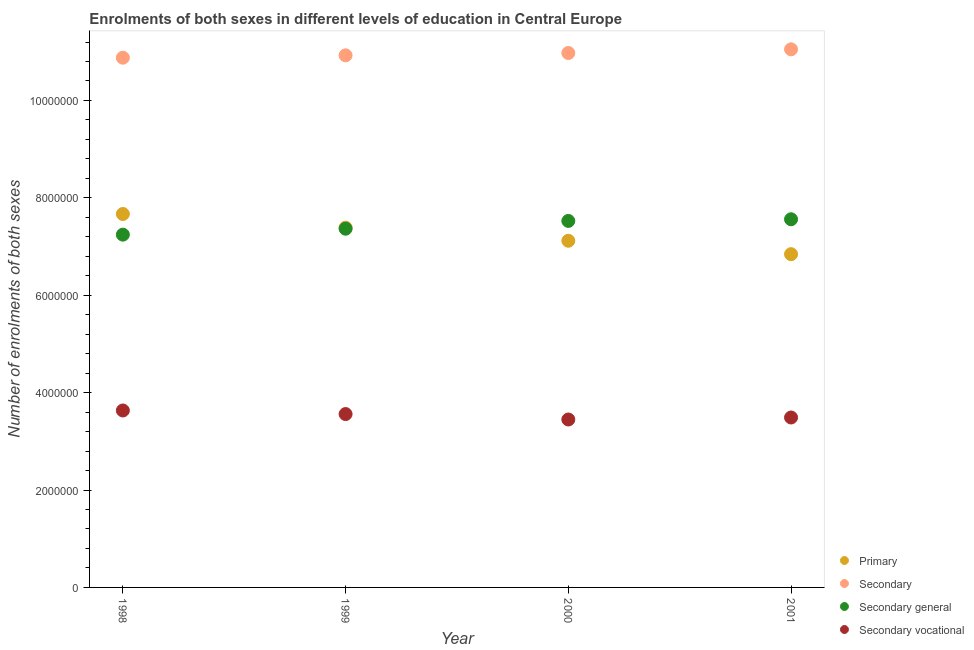How many different coloured dotlines are there?
Make the answer very short. 4. What is the number of enrolments in secondary education in 2000?
Provide a succinct answer. 1.10e+07. Across all years, what is the maximum number of enrolments in secondary general education?
Provide a succinct answer. 7.56e+06. Across all years, what is the minimum number of enrolments in primary education?
Provide a succinct answer. 6.84e+06. In which year was the number of enrolments in secondary education maximum?
Provide a succinct answer. 2001. In which year was the number of enrolments in secondary education minimum?
Give a very brief answer. 1998. What is the total number of enrolments in primary education in the graph?
Ensure brevity in your answer.  2.90e+07. What is the difference between the number of enrolments in secondary education in 1999 and that in 2000?
Your answer should be compact. -4.81e+04. What is the difference between the number of enrolments in primary education in 1999 and the number of enrolments in secondary education in 1998?
Offer a very short reply. -3.49e+06. What is the average number of enrolments in secondary education per year?
Your response must be concise. 1.10e+07. In the year 1999, what is the difference between the number of enrolments in secondary education and number of enrolments in secondary vocational education?
Provide a short and direct response. 7.37e+06. In how many years, is the number of enrolments in secondary vocational education greater than 10400000?
Provide a succinct answer. 0. What is the ratio of the number of enrolments in secondary vocational education in 1999 to that in 2000?
Provide a succinct answer. 1.03. What is the difference between the highest and the second highest number of enrolments in secondary vocational education?
Your answer should be very brief. 7.35e+04. What is the difference between the highest and the lowest number of enrolments in primary education?
Give a very brief answer. 8.25e+05. Is the sum of the number of enrolments in primary education in 2000 and 2001 greater than the maximum number of enrolments in secondary vocational education across all years?
Offer a terse response. Yes. Is it the case that in every year, the sum of the number of enrolments in primary education and number of enrolments in secondary education is greater than the number of enrolments in secondary general education?
Ensure brevity in your answer.  Yes. Is the number of enrolments in secondary vocational education strictly greater than the number of enrolments in secondary education over the years?
Provide a succinct answer. No. How many dotlines are there?
Offer a terse response. 4. Are the values on the major ticks of Y-axis written in scientific E-notation?
Give a very brief answer. No. Does the graph contain any zero values?
Ensure brevity in your answer.  No. Does the graph contain grids?
Ensure brevity in your answer.  No. How many legend labels are there?
Provide a short and direct response. 4. What is the title of the graph?
Keep it short and to the point. Enrolments of both sexes in different levels of education in Central Europe. What is the label or title of the X-axis?
Your answer should be compact. Year. What is the label or title of the Y-axis?
Your answer should be very brief. Number of enrolments of both sexes. What is the Number of enrolments of both sexes in Primary in 1998?
Your answer should be very brief. 7.67e+06. What is the Number of enrolments of both sexes in Secondary in 1998?
Keep it short and to the point. 1.09e+07. What is the Number of enrolments of both sexes in Secondary general in 1998?
Your answer should be compact. 7.24e+06. What is the Number of enrolments of both sexes of Secondary vocational in 1998?
Ensure brevity in your answer.  3.63e+06. What is the Number of enrolments of both sexes of Primary in 1999?
Your answer should be very brief. 7.39e+06. What is the Number of enrolments of both sexes of Secondary in 1999?
Ensure brevity in your answer.  1.09e+07. What is the Number of enrolments of both sexes in Secondary general in 1999?
Ensure brevity in your answer.  7.37e+06. What is the Number of enrolments of both sexes in Secondary vocational in 1999?
Provide a succinct answer. 3.56e+06. What is the Number of enrolments of both sexes in Primary in 2000?
Provide a short and direct response. 7.12e+06. What is the Number of enrolments of both sexes of Secondary in 2000?
Make the answer very short. 1.10e+07. What is the Number of enrolments of both sexes of Secondary general in 2000?
Your response must be concise. 7.53e+06. What is the Number of enrolments of both sexes of Secondary vocational in 2000?
Your answer should be compact. 3.45e+06. What is the Number of enrolments of both sexes in Primary in 2001?
Your answer should be compact. 6.84e+06. What is the Number of enrolments of both sexes in Secondary in 2001?
Give a very brief answer. 1.10e+07. What is the Number of enrolments of both sexes of Secondary general in 2001?
Provide a succinct answer. 7.56e+06. What is the Number of enrolments of both sexes in Secondary vocational in 2001?
Keep it short and to the point. 3.49e+06. Across all years, what is the maximum Number of enrolments of both sexes of Primary?
Your answer should be compact. 7.67e+06. Across all years, what is the maximum Number of enrolments of both sexes of Secondary?
Offer a terse response. 1.10e+07. Across all years, what is the maximum Number of enrolments of both sexes in Secondary general?
Provide a succinct answer. 7.56e+06. Across all years, what is the maximum Number of enrolments of both sexes of Secondary vocational?
Your answer should be compact. 3.63e+06. Across all years, what is the minimum Number of enrolments of both sexes in Primary?
Offer a very short reply. 6.84e+06. Across all years, what is the minimum Number of enrolments of both sexes in Secondary?
Offer a terse response. 1.09e+07. Across all years, what is the minimum Number of enrolments of both sexes in Secondary general?
Your answer should be very brief. 7.24e+06. Across all years, what is the minimum Number of enrolments of both sexes of Secondary vocational?
Give a very brief answer. 3.45e+06. What is the total Number of enrolments of both sexes in Primary in the graph?
Offer a very short reply. 2.90e+07. What is the total Number of enrolments of both sexes of Secondary in the graph?
Your answer should be very brief. 4.38e+07. What is the total Number of enrolments of both sexes in Secondary general in the graph?
Provide a succinct answer. 2.97e+07. What is the total Number of enrolments of both sexes in Secondary vocational in the graph?
Ensure brevity in your answer.  1.41e+07. What is the difference between the Number of enrolments of both sexes in Primary in 1998 and that in 1999?
Your answer should be compact. 2.81e+05. What is the difference between the Number of enrolments of both sexes in Secondary in 1998 and that in 1999?
Keep it short and to the point. -4.83e+04. What is the difference between the Number of enrolments of both sexes in Secondary general in 1998 and that in 1999?
Your answer should be very brief. -1.22e+05. What is the difference between the Number of enrolments of both sexes in Secondary vocational in 1998 and that in 1999?
Provide a succinct answer. 7.35e+04. What is the difference between the Number of enrolments of both sexes in Primary in 1998 and that in 2000?
Keep it short and to the point. 5.50e+05. What is the difference between the Number of enrolments of both sexes in Secondary in 1998 and that in 2000?
Your answer should be compact. -9.64e+04. What is the difference between the Number of enrolments of both sexes of Secondary general in 1998 and that in 2000?
Keep it short and to the point. -2.82e+05. What is the difference between the Number of enrolments of both sexes of Secondary vocational in 1998 and that in 2000?
Offer a terse response. 1.85e+05. What is the difference between the Number of enrolments of both sexes in Primary in 1998 and that in 2001?
Offer a very short reply. 8.25e+05. What is the difference between the Number of enrolments of both sexes of Secondary in 1998 and that in 2001?
Keep it short and to the point. -1.72e+05. What is the difference between the Number of enrolments of both sexes of Secondary general in 1998 and that in 2001?
Your answer should be compact. -3.16e+05. What is the difference between the Number of enrolments of both sexes of Secondary vocational in 1998 and that in 2001?
Ensure brevity in your answer.  1.44e+05. What is the difference between the Number of enrolments of both sexes of Primary in 1999 and that in 2000?
Keep it short and to the point. 2.68e+05. What is the difference between the Number of enrolments of both sexes in Secondary in 1999 and that in 2000?
Ensure brevity in your answer.  -4.81e+04. What is the difference between the Number of enrolments of both sexes in Secondary general in 1999 and that in 2000?
Your answer should be compact. -1.60e+05. What is the difference between the Number of enrolments of both sexes in Secondary vocational in 1999 and that in 2000?
Ensure brevity in your answer.  1.12e+05. What is the difference between the Number of enrolments of both sexes of Primary in 1999 and that in 2001?
Provide a short and direct response. 5.44e+05. What is the difference between the Number of enrolments of both sexes of Secondary in 1999 and that in 2001?
Offer a very short reply. -1.23e+05. What is the difference between the Number of enrolments of both sexes in Secondary general in 1999 and that in 2001?
Make the answer very short. -1.94e+05. What is the difference between the Number of enrolments of both sexes of Secondary vocational in 1999 and that in 2001?
Provide a short and direct response. 7.03e+04. What is the difference between the Number of enrolments of both sexes of Primary in 2000 and that in 2001?
Keep it short and to the point. 2.75e+05. What is the difference between the Number of enrolments of both sexes in Secondary in 2000 and that in 2001?
Give a very brief answer. -7.53e+04. What is the difference between the Number of enrolments of both sexes of Secondary general in 2000 and that in 2001?
Keep it short and to the point. -3.40e+04. What is the difference between the Number of enrolments of both sexes in Secondary vocational in 2000 and that in 2001?
Make the answer very short. -4.13e+04. What is the difference between the Number of enrolments of both sexes in Primary in 1998 and the Number of enrolments of both sexes in Secondary in 1999?
Give a very brief answer. -3.26e+06. What is the difference between the Number of enrolments of both sexes in Primary in 1998 and the Number of enrolments of both sexes in Secondary general in 1999?
Offer a very short reply. 3.02e+05. What is the difference between the Number of enrolments of both sexes of Primary in 1998 and the Number of enrolments of both sexes of Secondary vocational in 1999?
Make the answer very short. 4.11e+06. What is the difference between the Number of enrolments of both sexes in Secondary in 1998 and the Number of enrolments of both sexes in Secondary general in 1999?
Give a very brief answer. 3.51e+06. What is the difference between the Number of enrolments of both sexes in Secondary in 1998 and the Number of enrolments of both sexes in Secondary vocational in 1999?
Your answer should be compact. 7.32e+06. What is the difference between the Number of enrolments of both sexes of Secondary general in 1998 and the Number of enrolments of both sexes of Secondary vocational in 1999?
Your answer should be very brief. 3.68e+06. What is the difference between the Number of enrolments of both sexes of Primary in 1998 and the Number of enrolments of both sexes of Secondary in 2000?
Offer a terse response. -3.31e+06. What is the difference between the Number of enrolments of both sexes in Primary in 1998 and the Number of enrolments of both sexes in Secondary general in 2000?
Provide a succinct answer. 1.42e+05. What is the difference between the Number of enrolments of both sexes in Primary in 1998 and the Number of enrolments of both sexes in Secondary vocational in 2000?
Give a very brief answer. 4.22e+06. What is the difference between the Number of enrolments of both sexes of Secondary in 1998 and the Number of enrolments of both sexes of Secondary general in 2000?
Make the answer very short. 3.35e+06. What is the difference between the Number of enrolments of both sexes in Secondary in 1998 and the Number of enrolments of both sexes in Secondary vocational in 2000?
Offer a terse response. 7.43e+06. What is the difference between the Number of enrolments of both sexes in Secondary general in 1998 and the Number of enrolments of both sexes in Secondary vocational in 2000?
Make the answer very short. 3.80e+06. What is the difference between the Number of enrolments of both sexes in Primary in 1998 and the Number of enrolments of both sexes in Secondary in 2001?
Offer a very short reply. -3.38e+06. What is the difference between the Number of enrolments of both sexes of Primary in 1998 and the Number of enrolments of both sexes of Secondary general in 2001?
Provide a short and direct response. 1.08e+05. What is the difference between the Number of enrolments of both sexes in Primary in 1998 and the Number of enrolments of both sexes in Secondary vocational in 2001?
Offer a very short reply. 4.18e+06. What is the difference between the Number of enrolments of both sexes in Secondary in 1998 and the Number of enrolments of both sexes in Secondary general in 2001?
Your answer should be very brief. 3.32e+06. What is the difference between the Number of enrolments of both sexes in Secondary in 1998 and the Number of enrolments of both sexes in Secondary vocational in 2001?
Your response must be concise. 7.39e+06. What is the difference between the Number of enrolments of both sexes in Secondary general in 1998 and the Number of enrolments of both sexes in Secondary vocational in 2001?
Keep it short and to the point. 3.75e+06. What is the difference between the Number of enrolments of both sexes in Primary in 1999 and the Number of enrolments of both sexes in Secondary in 2000?
Provide a succinct answer. -3.59e+06. What is the difference between the Number of enrolments of both sexes of Primary in 1999 and the Number of enrolments of both sexes of Secondary general in 2000?
Make the answer very short. -1.39e+05. What is the difference between the Number of enrolments of both sexes of Primary in 1999 and the Number of enrolments of both sexes of Secondary vocational in 2000?
Make the answer very short. 3.94e+06. What is the difference between the Number of enrolments of both sexes in Secondary in 1999 and the Number of enrolments of both sexes in Secondary general in 2000?
Offer a terse response. 3.40e+06. What is the difference between the Number of enrolments of both sexes of Secondary in 1999 and the Number of enrolments of both sexes of Secondary vocational in 2000?
Your answer should be compact. 7.48e+06. What is the difference between the Number of enrolments of both sexes in Secondary general in 1999 and the Number of enrolments of both sexes in Secondary vocational in 2000?
Your answer should be very brief. 3.92e+06. What is the difference between the Number of enrolments of both sexes of Primary in 1999 and the Number of enrolments of both sexes of Secondary in 2001?
Offer a very short reply. -3.66e+06. What is the difference between the Number of enrolments of both sexes in Primary in 1999 and the Number of enrolments of both sexes in Secondary general in 2001?
Keep it short and to the point. -1.73e+05. What is the difference between the Number of enrolments of both sexes in Primary in 1999 and the Number of enrolments of both sexes in Secondary vocational in 2001?
Provide a succinct answer. 3.90e+06. What is the difference between the Number of enrolments of both sexes in Secondary in 1999 and the Number of enrolments of both sexes in Secondary general in 2001?
Make the answer very short. 3.37e+06. What is the difference between the Number of enrolments of both sexes in Secondary in 1999 and the Number of enrolments of both sexes in Secondary vocational in 2001?
Give a very brief answer. 7.44e+06. What is the difference between the Number of enrolments of both sexes in Secondary general in 1999 and the Number of enrolments of both sexes in Secondary vocational in 2001?
Give a very brief answer. 3.88e+06. What is the difference between the Number of enrolments of both sexes in Primary in 2000 and the Number of enrolments of both sexes in Secondary in 2001?
Give a very brief answer. -3.93e+06. What is the difference between the Number of enrolments of both sexes in Primary in 2000 and the Number of enrolments of both sexes in Secondary general in 2001?
Keep it short and to the point. -4.41e+05. What is the difference between the Number of enrolments of both sexes of Primary in 2000 and the Number of enrolments of both sexes of Secondary vocational in 2001?
Give a very brief answer. 3.63e+06. What is the difference between the Number of enrolments of both sexes of Secondary in 2000 and the Number of enrolments of both sexes of Secondary general in 2001?
Your response must be concise. 3.41e+06. What is the difference between the Number of enrolments of both sexes of Secondary in 2000 and the Number of enrolments of both sexes of Secondary vocational in 2001?
Your answer should be compact. 7.48e+06. What is the difference between the Number of enrolments of both sexes of Secondary general in 2000 and the Number of enrolments of both sexes of Secondary vocational in 2001?
Provide a short and direct response. 4.04e+06. What is the average Number of enrolments of both sexes in Primary per year?
Provide a short and direct response. 7.25e+06. What is the average Number of enrolments of both sexes in Secondary per year?
Your answer should be compact. 1.10e+07. What is the average Number of enrolments of both sexes in Secondary general per year?
Provide a succinct answer. 7.42e+06. What is the average Number of enrolments of both sexes in Secondary vocational per year?
Your response must be concise. 3.53e+06. In the year 1998, what is the difference between the Number of enrolments of both sexes of Primary and Number of enrolments of both sexes of Secondary?
Your response must be concise. -3.21e+06. In the year 1998, what is the difference between the Number of enrolments of both sexes in Primary and Number of enrolments of both sexes in Secondary general?
Provide a succinct answer. 4.24e+05. In the year 1998, what is the difference between the Number of enrolments of both sexes of Primary and Number of enrolments of both sexes of Secondary vocational?
Provide a succinct answer. 4.03e+06. In the year 1998, what is the difference between the Number of enrolments of both sexes in Secondary and Number of enrolments of both sexes in Secondary general?
Your answer should be compact. 3.63e+06. In the year 1998, what is the difference between the Number of enrolments of both sexes in Secondary and Number of enrolments of both sexes in Secondary vocational?
Give a very brief answer. 7.24e+06. In the year 1998, what is the difference between the Number of enrolments of both sexes of Secondary general and Number of enrolments of both sexes of Secondary vocational?
Provide a short and direct response. 3.61e+06. In the year 1999, what is the difference between the Number of enrolments of both sexes in Primary and Number of enrolments of both sexes in Secondary?
Ensure brevity in your answer.  -3.54e+06. In the year 1999, what is the difference between the Number of enrolments of both sexes of Primary and Number of enrolments of both sexes of Secondary general?
Your response must be concise. 2.06e+04. In the year 1999, what is the difference between the Number of enrolments of both sexes in Primary and Number of enrolments of both sexes in Secondary vocational?
Ensure brevity in your answer.  3.83e+06. In the year 1999, what is the difference between the Number of enrolments of both sexes in Secondary and Number of enrolments of both sexes in Secondary general?
Your response must be concise. 3.56e+06. In the year 1999, what is the difference between the Number of enrolments of both sexes in Secondary and Number of enrolments of both sexes in Secondary vocational?
Your answer should be compact. 7.37e+06. In the year 1999, what is the difference between the Number of enrolments of both sexes of Secondary general and Number of enrolments of both sexes of Secondary vocational?
Offer a terse response. 3.81e+06. In the year 2000, what is the difference between the Number of enrolments of both sexes in Primary and Number of enrolments of both sexes in Secondary?
Give a very brief answer. -3.86e+06. In the year 2000, what is the difference between the Number of enrolments of both sexes in Primary and Number of enrolments of both sexes in Secondary general?
Give a very brief answer. -4.07e+05. In the year 2000, what is the difference between the Number of enrolments of both sexes of Primary and Number of enrolments of both sexes of Secondary vocational?
Ensure brevity in your answer.  3.67e+06. In the year 2000, what is the difference between the Number of enrolments of both sexes in Secondary and Number of enrolments of both sexes in Secondary general?
Ensure brevity in your answer.  3.45e+06. In the year 2000, what is the difference between the Number of enrolments of both sexes in Secondary and Number of enrolments of both sexes in Secondary vocational?
Your response must be concise. 7.53e+06. In the year 2000, what is the difference between the Number of enrolments of both sexes in Secondary general and Number of enrolments of both sexes in Secondary vocational?
Give a very brief answer. 4.08e+06. In the year 2001, what is the difference between the Number of enrolments of both sexes of Primary and Number of enrolments of both sexes of Secondary?
Give a very brief answer. -4.21e+06. In the year 2001, what is the difference between the Number of enrolments of both sexes in Primary and Number of enrolments of both sexes in Secondary general?
Offer a terse response. -7.17e+05. In the year 2001, what is the difference between the Number of enrolments of both sexes of Primary and Number of enrolments of both sexes of Secondary vocational?
Your response must be concise. 3.35e+06. In the year 2001, what is the difference between the Number of enrolments of both sexes in Secondary and Number of enrolments of both sexes in Secondary general?
Offer a terse response. 3.49e+06. In the year 2001, what is the difference between the Number of enrolments of both sexes in Secondary and Number of enrolments of both sexes in Secondary vocational?
Make the answer very short. 7.56e+06. In the year 2001, what is the difference between the Number of enrolments of both sexes in Secondary general and Number of enrolments of both sexes in Secondary vocational?
Offer a very short reply. 4.07e+06. What is the ratio of the Number of enrolments of both sexes in Primary in 1998 to that in 1999?
Your answer should be very brief. 1.04. What is the ratio of the Number of enrolments of both sexes of Secondary general in 1998 to that in 1999?
Your answer should be compact. 0.98. What is the ratio of the Number of enrolments of both sexes of Secondary vocational in 1998 to that in 1999?
Your response must be concise. 1.02. What is the ratio of the Number of enrolments of both sexes of Primary in 1998 to that in 2000?
Ensure brevity in your answer.  1.08. What is the ratio of the Number of enrolments of both sexes in Secondary in 1998 to that in 2000?
Ensure brevity in your answer.  0.99. What is the ratio of the Number of enrolments of both sexes of Secondary general in 1998 to that in 2000?
Give a very brief answer. 0.96. What is the ratio of the Number of enrolments of both sexes in Secondary vocational in 1998 to that in 2000?
Your answer should be very brief. 1.05. What is the ratio of the Number of enrolments of both sexes of Primary in 1998 to that in 2001?
Your answer should be compact. 1.12. What is the ratio of the Number of enrolments of both sexes of Secondary in 1998 to that in 2001?
Provide a succinct answer. 0.98. What is the ratio of the Number of enrolments of both sexes in Secondary vocational in 1998 to that in 2001?
Offer a very short reply. 1.04. What is the ratio of the Number of enrolments of both sexes in Primary in 1999 to that in 2000?
Give a very brief answer. 1.04. What is the ratio of the Number of enrolments of both sexes in Secondary general in 1999 to that in 2000?
Provide a succinct answer. 0.98. What is the ratio of the Number of enrolments of both sexes of Secondary vocational in 1999 to that in 2000?
Keep it short and to the point. 1.03. What is the ratio of the Number of enrolments of both sexes in Primary in 1999 to that in 2001?
Offer a very short reply. 1.08. What is the ratio of the Number of enrolments of both sexes in Secondary in 1999 to that in 2001?
Your answer should be very brief. 0.99. What is the ratio of the Number of enrolments of both sexes of Secondary general in 1999 to that in 2001?
Your answer should be compact. 0.97. What is the ratio of the Number of enrolments of both sexes in Secondary vocational in 1999 to that in 2001?
Provide a succinct answer. 1.02. What is the ratio of the Number of enrolments of both sexes in Primary in 2000 to that in 2001?
Offer a terse response. 1.04. What is the ratio of the Number of enrolments of both sexes in Secondary in 2000 to that in 2001?
Your answer should be very brief. 0.99. What is the difference between the highest and the second highest Number of enrolments of both sexes of Primary?
Offer a terse response. 2.81e+05. What is the difference between the highest and the second highest Number of enrolments of both sexes in Secondary?
Your response must be concise. 7.53e+04. What is the difference between the highest and the second highest Number of enrolments of both sexes in Secondary general?
Give a very brief answer. 3.40e+04. What is the difference between the highest and the second highest Number of enrolments of both sexes of Secondary vocational?
Your response must be concise. 7.35e+04. What is the difference between the highest and the lowest Number of enrolments of both sexes of Primary?
Ensure brevity in your answer.  8.25e+05. What is the difference between the highest and the lowest Number of enrolments of both sexes in Secondary?
Offer a terse response. 1.72e+05. What is the difference between the highest and the lowest Number of enrolments of both sexes of Secondary general?
Make the answer very short. 3.16e+05. What is the difference between the highest and the lowest Number of enrolments of both sexes of Secondary vocational?
Offer a very short reply. 1.85e+05. 